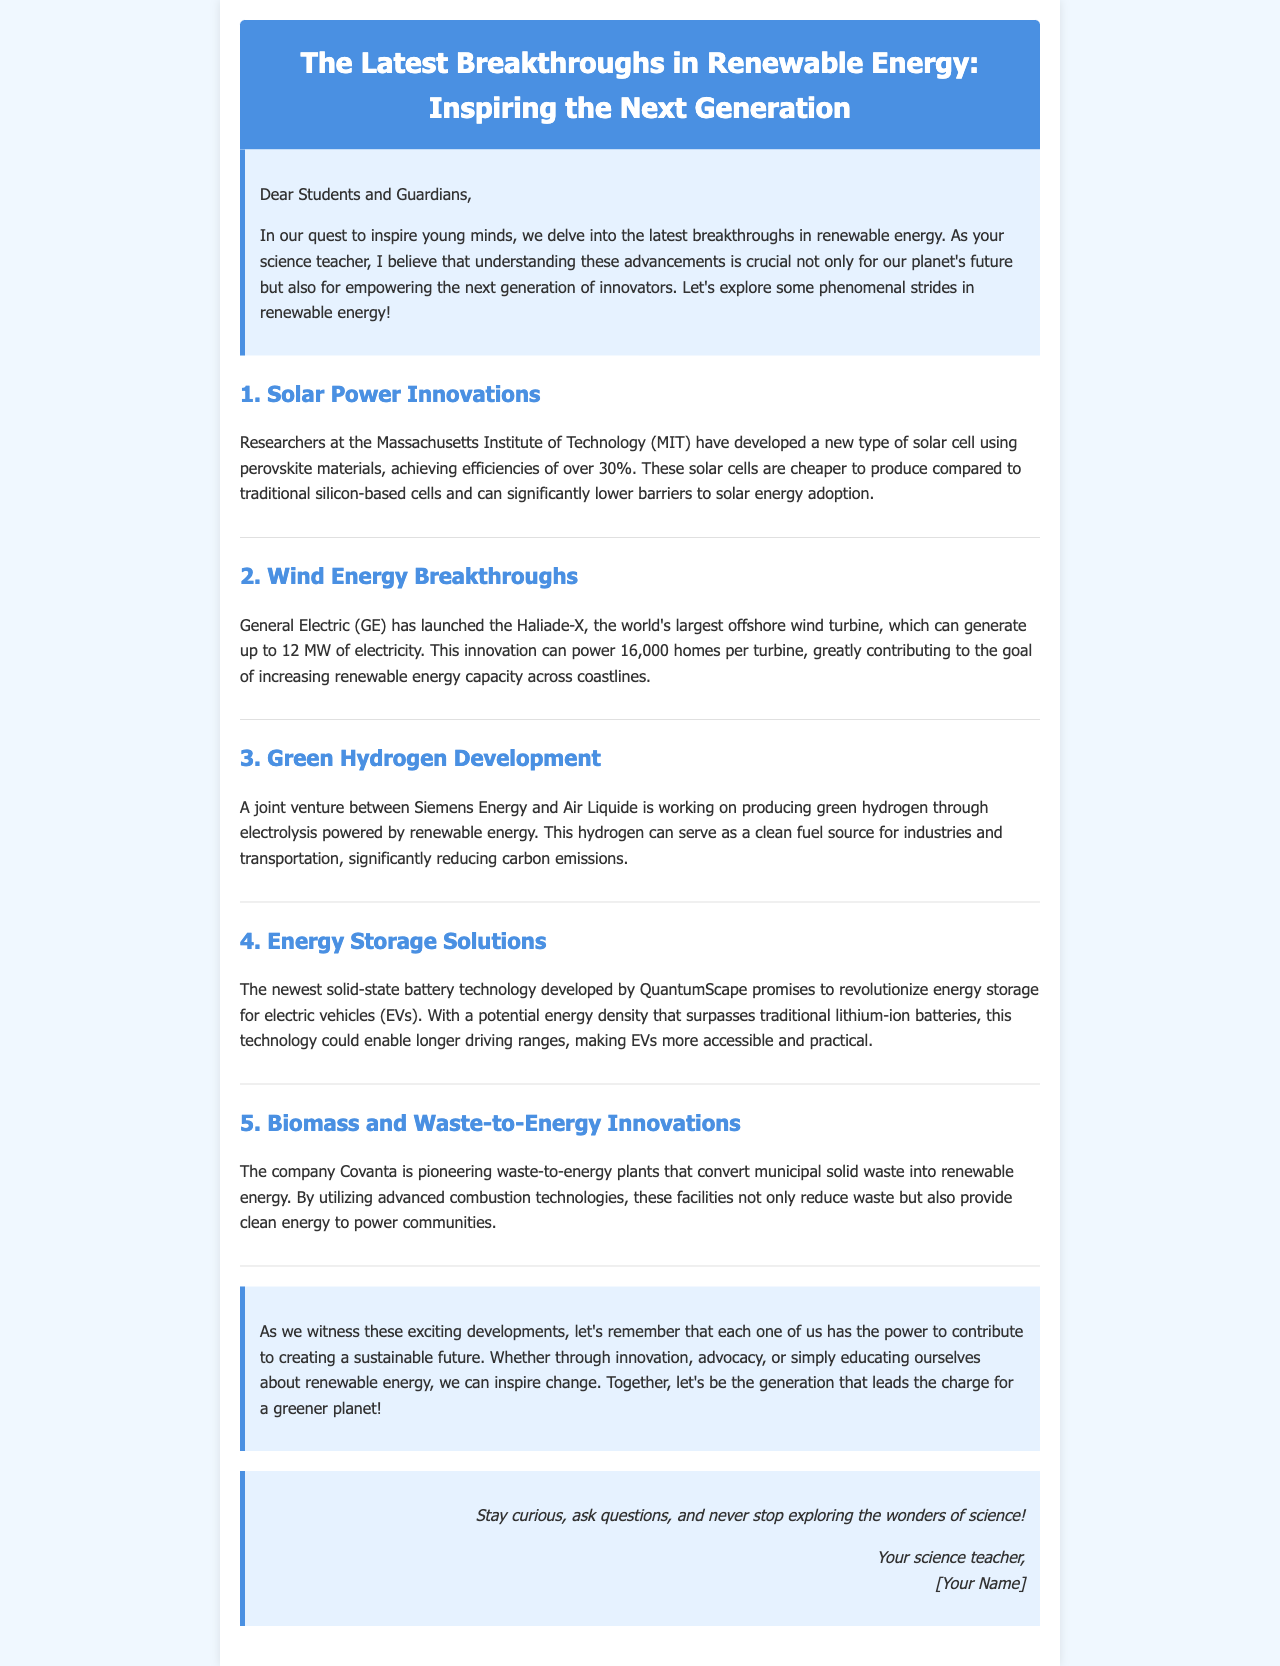What type of solar cells have MIT researchers developed? The document states that MIT researchers developed a new type of solar cell using perovskite materials.
Answer: perovskite materials How much electricity can the Haliade-X turbine generate? According to the document, the Haliade-X can generate up to 12 MW of electricity.
Answer: 12 MW What company is working on green hydrogen production? The document mentions that Siemens Energy and Air Liquide are collaborating on green hydrogen production.
Answer: Siemens Energy and Air Liquide What technology could revolutionize energy storage for electric vehicles? The document indicates that a new solid-state battery technology developed by QuantumScape has that potential.
Answer: solid-state battery technology What is the main purpose of Covanta's waste-to-energy plants? The document describes Covanta's plants as converting municipal solid waste into renewable energy.
Answer: convert municipal solid waste into renewable energy Which generation does the document aim to inspire regarding renewable energy? It mentions inspiring the next generation of innovators and leaders in sustainability.
Answer: next generation How does the newsletter encourage students to engage with science? The document invites students to stay curious, ask questions, and explore science further.
Answer: stay curious, ask questions What type of innovations are highlighted in the newsletter's sections? The document discusses various breakthroughs in renewable energy technologies.
Answer: breakthroughs in renewable energy technologies 